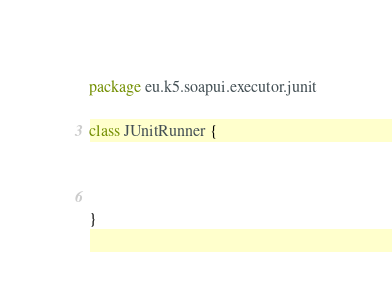Convert code to text. <code><loc_0><loc_0><loc_500><loc_500><_Kotlin_>package eu.k5.soapui.executor.junit

class JUnitRunner {



}</code> 